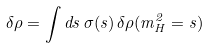Convert formula to latex. <formula><loc_0><loc_0><loc_500><loc_500>\delta \rho = \int d s \, \sigma ( s ) \, \delta \rho ( m _ { H } ^ { 2 } = s )</formula> 